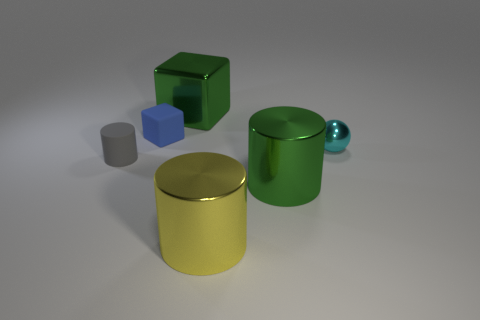How many yellow things have the same shape as the blue thing?
Provide a short and direct response. 0. There is a thing that is the same color as the large block; what is its material?
Your answer should be compact. Metal. Do the small cylinder and the small cube have the same material?
Ensure brevity in your answer.  Yes. There is a metal object in front of the large green metallic thing that is to the right of the yellow shiny thing; how many large green metal cylinders are to the right of it?
Make the answer very short. 1. Is there a tiny cylinder that has the same material as the tiny blue cube?
Make the answer very short. Yes. Are there fewer tiny blue matte cubes than small red metallic blocks?
Your answer should be compact. No. There is a big shiny cylinder behind the yellow metal thing; is its color the same as the big metal block?
Your answer should be compact. Yes. What is the material of the gray object that is behind the green cylinder in front of the large green shiny thing that is behind the tiny cube?
Your response must be concise. Rubber. Is there a large metal thing of the same color as the large block?
Your answer should be very brief. Yes. Is the number of blue cubes in front of the large yellow object less than the number of tiny gray cylinders?
Ensure brevity in your answer.  Yes. 